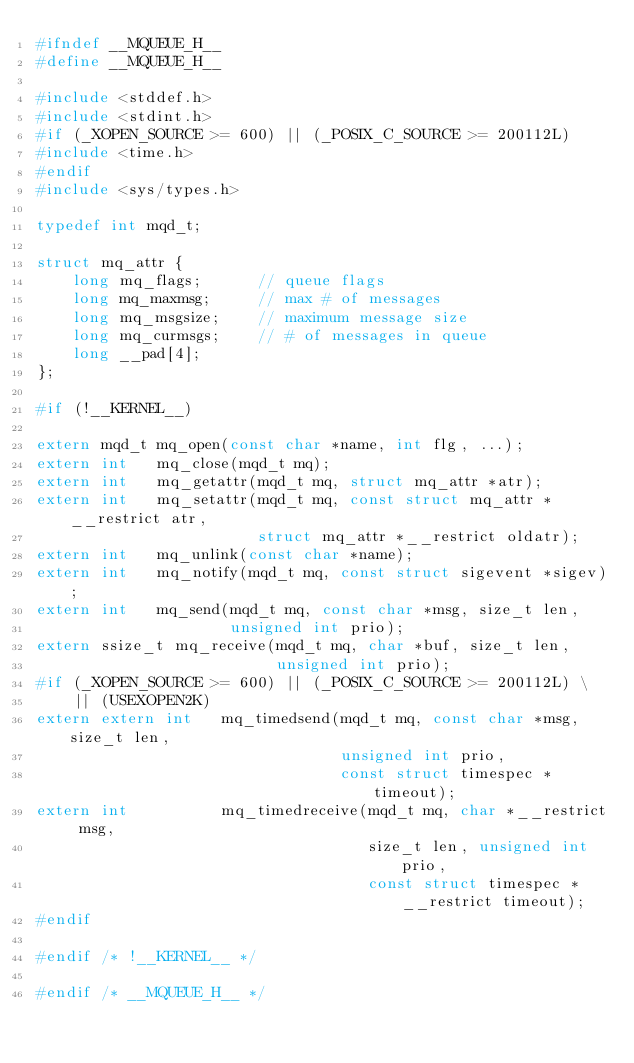Convert code to text. <code><loc_0><loc_0><loc_500><loc_500><_C_>#ifndef __MQUEUE_H__
#define __MQUEUE_H__

#include <stddef.h>
#include <stdint.h>
#if (_XOPEN_SOURCE >= 600) || (_POSIX_C_SOURCE >= 200112L)
#include <time.h>
#endif
#include <sys/types.h>

typedef int mqd_t;

struct mq_attr {
    long mq_flags;      // queue flags
    long mq_maxmsg;     // max # of messages
    long mq_msgsize;    // maximum message size
    long mq_curmsgs;    // # of messages in queue
    long __pad[4];
};

#if (!__KERNEL__)

extern mqd_t mq_open(const char *name, int flg, ...);
extern int   mq_close(mqd_t mq);
extern int   mq_getattr(mqd_t mq, struct mq_attr *atr);
extern int   mq_setattr(mqd_t mq, const struct mq_attr *__restrict atr,
                        struct mq_attr *__restrict oldatr);
extern int   mq_unlink(const char *name);
extern int   mq_notify(mqd_t mq, const struct sigevent *sigev);
extern int   mq_send(mqd_t mq, const char *msg, size_t len,
                     unsigned int prio);
extern ssize_t mq_receive(mqd_t mq, char *buf, size_t len,
                          unsigned int prio);
#if (_XOPEN_SOURCE >= 600) || (_POSIX_C_SOURCE >= 200112L) \
    || (USEXOPEN2K)
extern extern int   mq_timedsend(mqd_t mq, const char *msg, size_t len,
                                 unsigned int prio,
                                 const struct timespec *timeout);
extern int          mq_timedreceive(mqd_t mq, char *__restrict msg,
                                    size_t len, unsigned int prio,
                                    const struct timespec *__restrict timeout);
#endif

#endif /* !__KERNEL__ */

#endif /* __MQUEUE_H__ */

</code> 